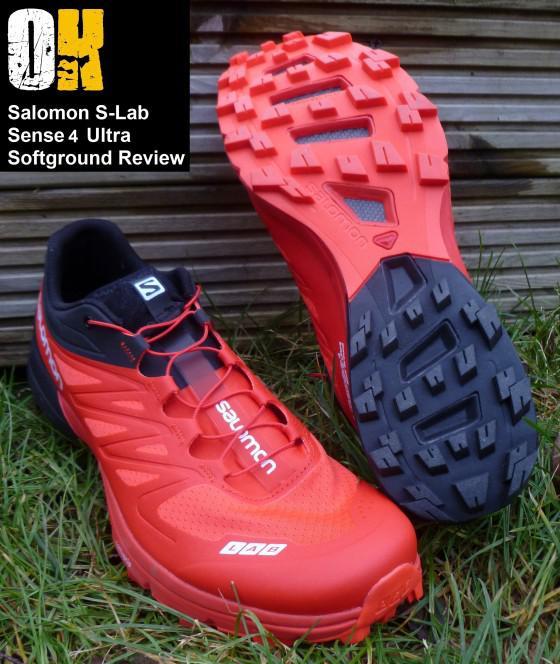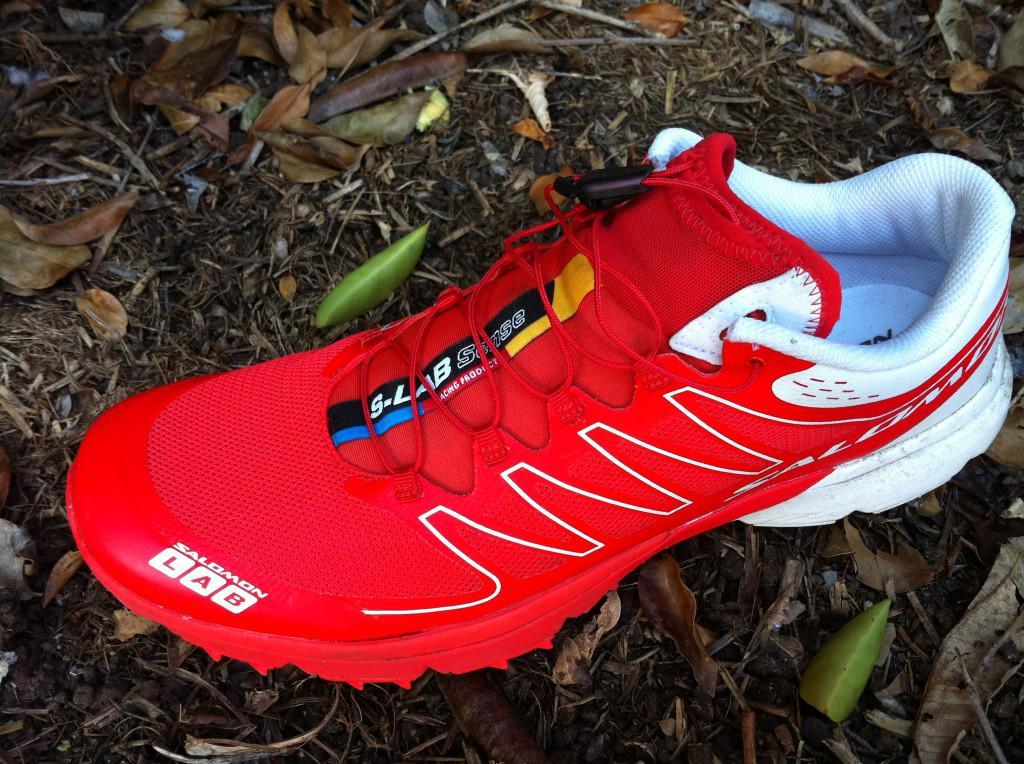The first image is the image on the left, the second image is the image on the right. Evaluate the accuracy of this statement regarding the images: "All of the shoes in the images are being displayed indoors.". Is it true? Answer yes or no. No. 